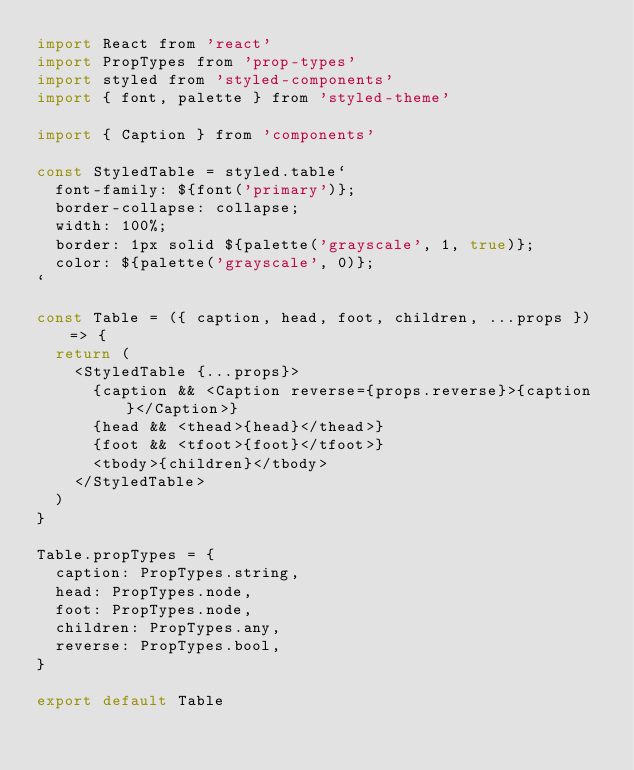<code> <loc_0><loc_0><loc_500><loc_500><_JavaScript_>import React from 'react'
import PropTypes from 'prop-types'
import styled from 'styled-components'
import { font, palette } from 'styled-theme'

import { Caption } from 'components'

const StyledTable = styled.table`
  font-family: ${font('primary')};
  border-collapse: collapse;
  width: 100%;
  border: 1px solid ${palette('grayscale', 1, true)};
  color: ${palette('grayscale', 0)};
`

const Table = ({ caption, head, foot, children, ...props }) => {
  return (
    <StyledTable {...props}>
      {caption && <Caption reverse={props.reverse}>{caption}</Caption>}
      {head && <thead>{head}</thead>}
      {foot && <tfoot>{foot}</tfoot>}
      <tbody>{children}</tbody>
    </StyledTable>
  )
}

Table.propTypes = {
  caption: PropTypes.string,
  head: PropTypes.node,
  foot: PropTypes.node,
  children: PropTypes.any,
  reverse: PropTypes.bool,
}

export default Table
</code> 